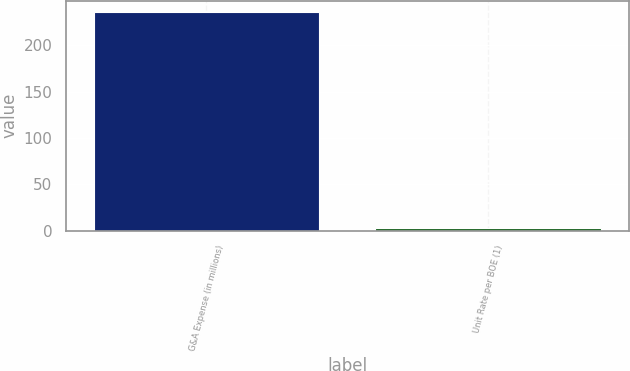<chart> <loc_0><loc_0><loc_500><loc_500><bar_chart><fcel>G&A Expense (in millions)<fcel>Unit Rate per BOE (1)<nl><fcel>236<fcel>3.12<nl></chart> 